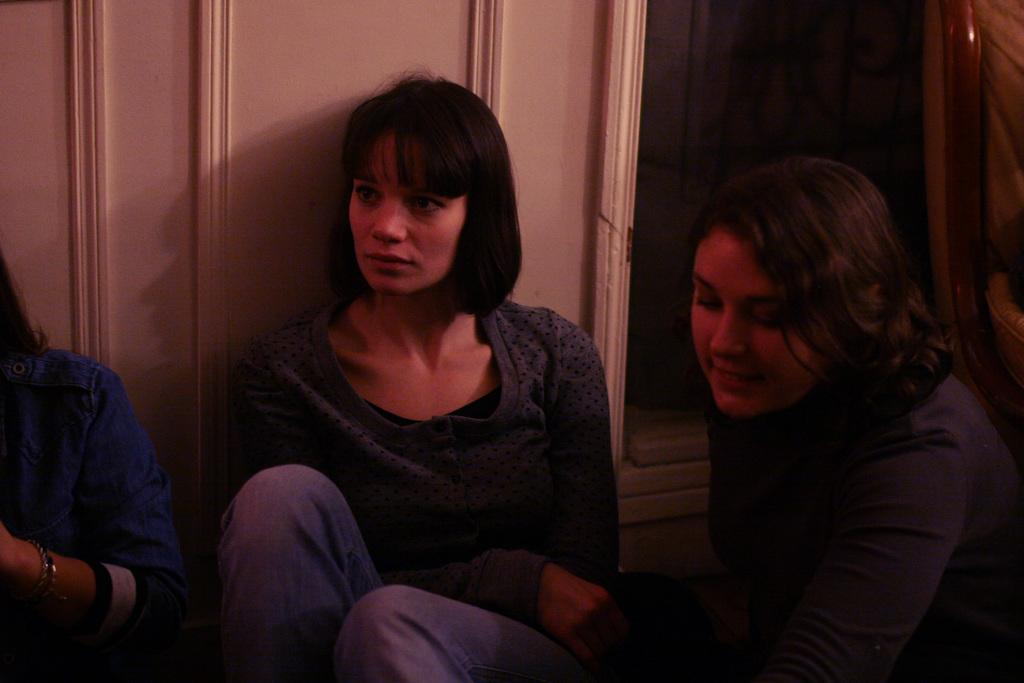How many persons are in the image? There are persons in the image, but the exact number is not specified. What are the persons doing in the image? The persons are sitting in the image. What can be observed about the clothing of the persons? The persons are wearing different color dresses in the image. What is the color of the wall in the background of the image? There is a white wall in the background of the image. What type of yam is being served to the persons in the image? There is no yam present in the image; the persons are wearing different color dresses while sitting. Can you tell me how many yaks are visible in the image? There are no yaks present in the image; the focus is on the persons sitting and their clothing. 